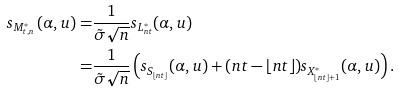Convert formula to latex. <formula><loc_0><loc_0><loc_500><loc_500>s _ { M _ { t , n } ^ { * } } \, ( \alpha , u ) = & \frac { 1 } { \tilde { \sigma } \sqrt { n } } s _ { L _ { n t } ^ { * } } ( \alpha , u ) \\ = & \frac { 1 } { \tilde { \sigma } \sqrt { n } } \left ( s _ { S _ { \lfloor n t \rfloor } } ( \alpha , u ) + ( n t - \lfloor n t \rfloor ) s _ { X _ { \lfloor n t \rfloor + 1 } ^ { * } } ( \alpha , u ) \right ) .</formula> 